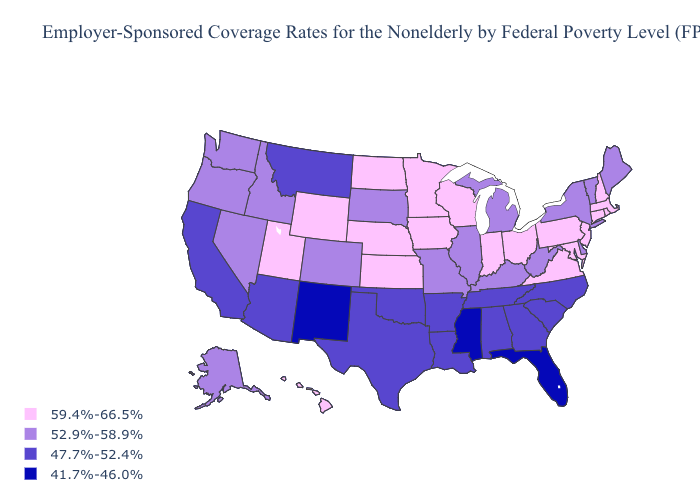Name the states that have a value in the range 59.4%-66.5%?
Write a very short answer. Connecticut, Hawaii, Indiana, Iowa, Kansas, Maryland, Massachusetts, Minnesota, Nebraska, New Hampshire, New Jersey, North Dakota, Ohio, Pennsylvania, Rhode Island, Utah, Virginia, Wisconsin, Wyoming. Name the states that have a value in the range 59.4%-66.5%?
Quick response, please. Connecticut, Hawaii, Indiana, Iowa, Kansas, Maryland, Massachusetts, Minnesota, Nebraska, New Hampshire, New Jersey, North Dakota, Ohio, Pennsylvania, Rhode Island, Utah, Virginia, Wisconsin, Wyoming. What is the highest value in the South ?
Give a very brief answer. 59.4%-66.5%. What is the value of Michigan?
Keep it brief. 52.9%-58.9%. Name the states that have a value in the range 41.7%-46.0%?
Give a very brief answer. Florida, Mississippi, New Mexico. What is the value of Indiana?
Be succinct. 59.4%-66.5%. What is the value of Oregon?
Answer briefly. 52.9%-58.9%. What is the lowest value in the South?
Concise answer only. 41.7%-46.0%. Does Vermont have the lowest value in the Northeast?
Answer briefly. Yes. What is the highest value in states that border New Mexico?
Quick response, please. 59.4%-66.5%. Does Maine have a higher value than Louisiana?
Concise answer only. Yes. What is the value of Nevada?
Quick response, please. 52.9%-58.9%. What is the value of Alabama?
Short answer required. 47.7%-52.4%. What is the lowest value in the USA?
Short answer required. 41.7%-46.0%. Is the legend a continuous bar?
Quick response, please. No. 